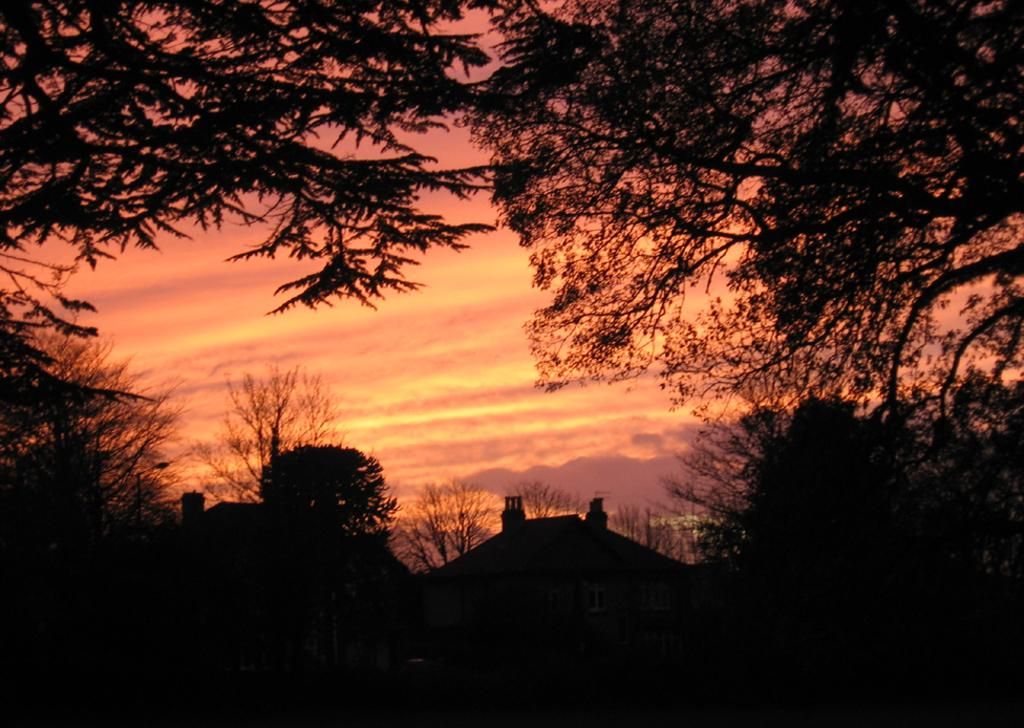What is the overall lighting condition in the image? The image appears dark. What type of natural elements can be seen in the image? There are trees in the image. What type of man-made structures are present in the image? There are buildings in the image. What part of the natural environment is visible in the image? The sky is visible in the image. What is the opinion of the trees about the buildings in the image? Trees do not have opinions, as they are inanimate objects. 